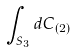<formula> <loc_0><loc_0><loc_500><loc_500>\int _ { S _ { 3 } } d C _ { ( 2 ) }</formula> 